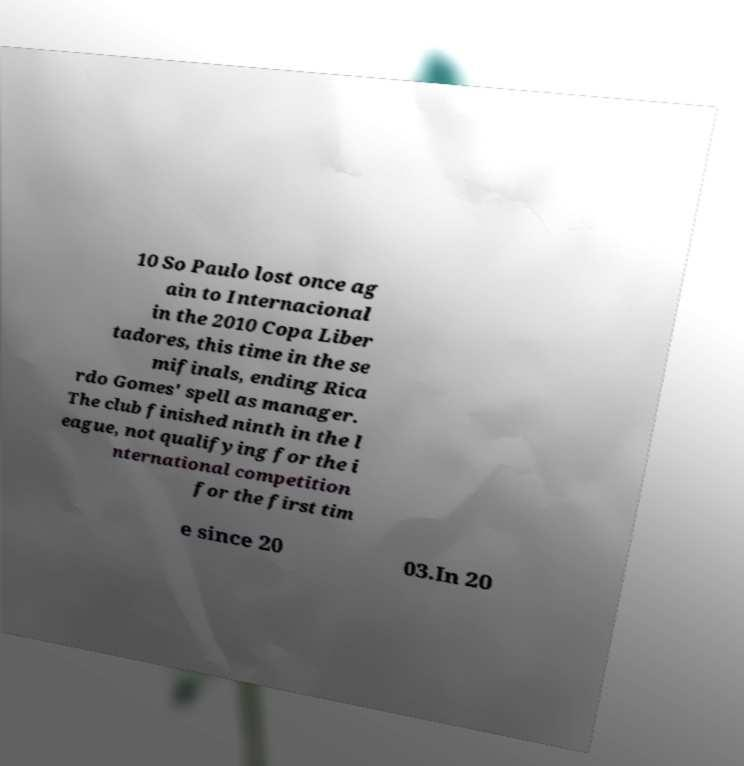Could you assist in decoding the text presented in this image and type it out clearly? 10 So Paulo lost once ag ain to Internacional in the 2010 Copa Liber tadores, this time in the se mifinals, ending Rica rdo Gomes' spell as manager. The club finished ninth in the l eague, not qualifying for the i nternational competition for the first tim e since 20 03.In 20 